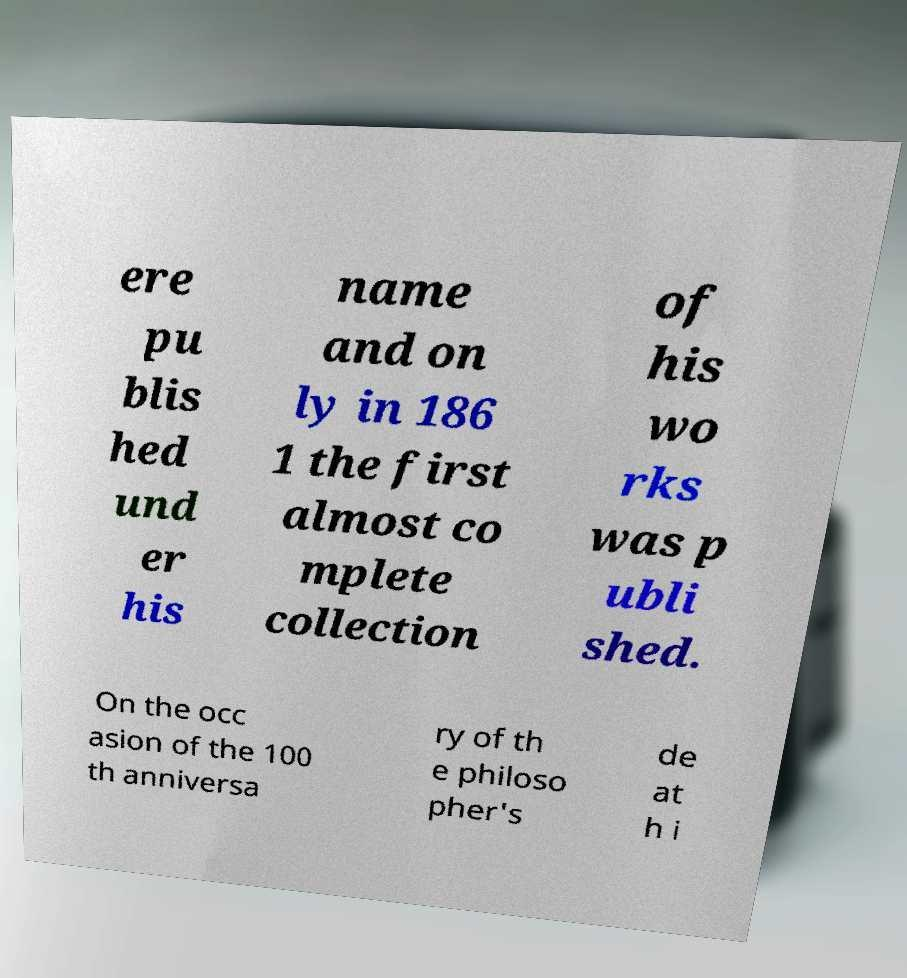Could you extract and type out the text from this image? ere pu blis hed und er his name and on ly in 186 1 the first almost co mplete collection of his wo rks was p ubli shed. On the occ asion of the 100 th anniversa ry of th e philoso pher's de at h i 